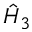Convert formula to latex. <formula><loc_0><loc_0><loc_500><loc_500>\hat { H } _ { 3 }</formula> 